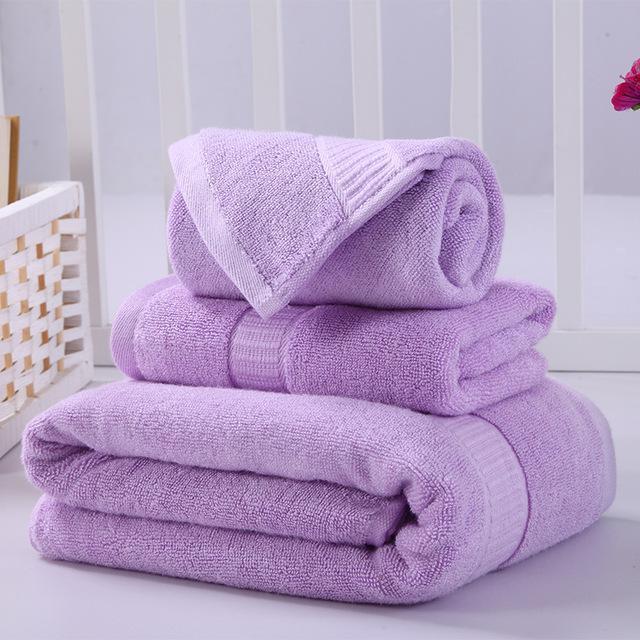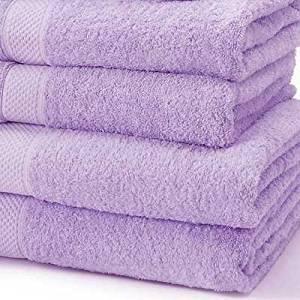The first image is the image on the left, the second image is the image on the right. Evaluate the accuracy of this statement regarding the images: "There are two stacks of towels and they are not both the exact same color.". Is it true? Answer yes or no. No. The first image is the image on the left, the second image is the image on the right. For the images shown, is this caption "There are exactly three towels in the right image." true? Answer yes or no. No. 